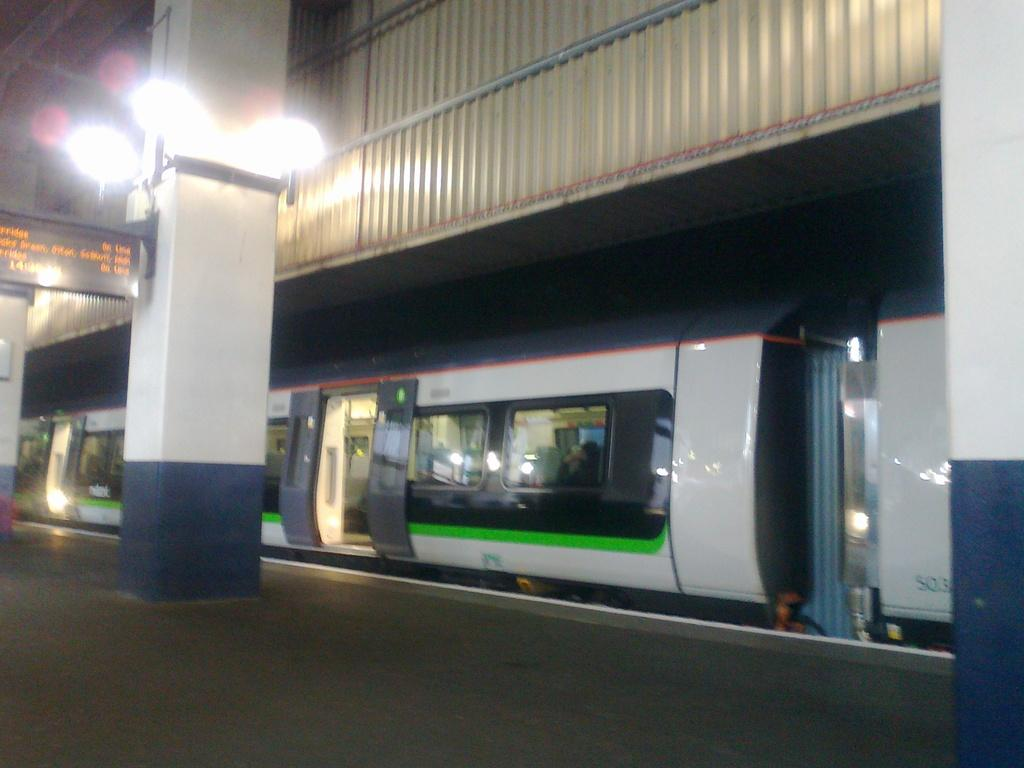What is the main subject of the image? The main subject of the image is a train. What can be seen on the left side of the image? There is a pillar on the left side of the image. What features are present on the pillar? The pillar has lights and a screen on it. How many fingers can be seen on the train in the image? There are no fingers visible in the image, as it features a train and a pillar with lights and a screen. 